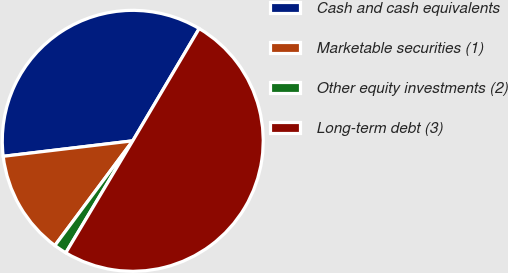Convert chart to OTSL. <chart><loc_0><loc_0><loc_500><loc_500><pie_chart><fcel>Cash and cash equivalents<fcel>Marketable securities (1)<fcel>Other equity investments (2)<fcel>Long-term debt (3)<nl><fcel>35.4%<fcel>12.93%<fcel>1.6%<fcel>50.07%<nl></chart> 